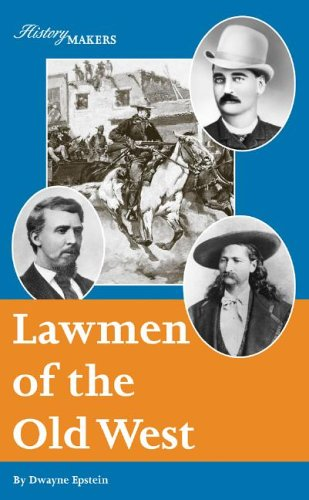What is the title of this book? The title of the book shown in the image is 'Lawmen of the Old West (History Makers)', a historical account that brings to life the stories of renowned lawmen from America's frontier days. 